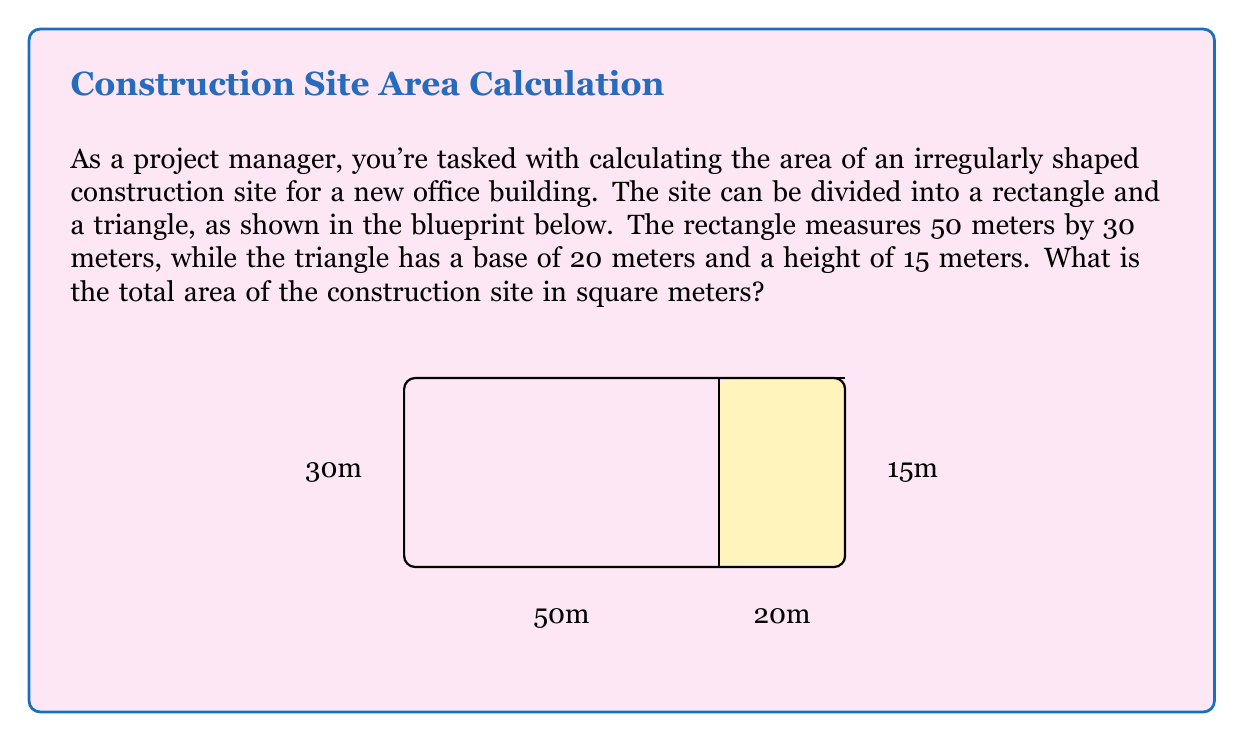Show me your answer to this math problem. To calculate the total area of the irregularly shaped construction site, we need to add the areas of the rectangle and the triangle. Let's break it down step-by-step:

1. Calculate the area of the rectangle:
   $$ A_{rectangle} = length \times width $$
   $$ A_{rectangle} = 50 \text{ m} \times 30 \text{ m} = 1500 \text{ m}^2 $$

2. Calculate the area of the triangle:
   $$ A_{triangle} = \frac{1}{2} \times base \times height $$
   $$ A_{triangle} = \frac{1}{2} \times 20 \text{ m} \times 15 \text{ m} = 150 \text{ m}^2 $$

3. Sum up the areas to get the total area of the construction site:
   $$ A_{total} = A_{rectangle} + A_{triangle} $$
   $$ A_{total} = 1500 \text{ m}^2 + 150 \text{ m}^2 = 1650 \text{ m}^2 $$

Therefore, the total area of the irregularly shaped construction site is 1650 square meters.
Answer: 1650 m² 